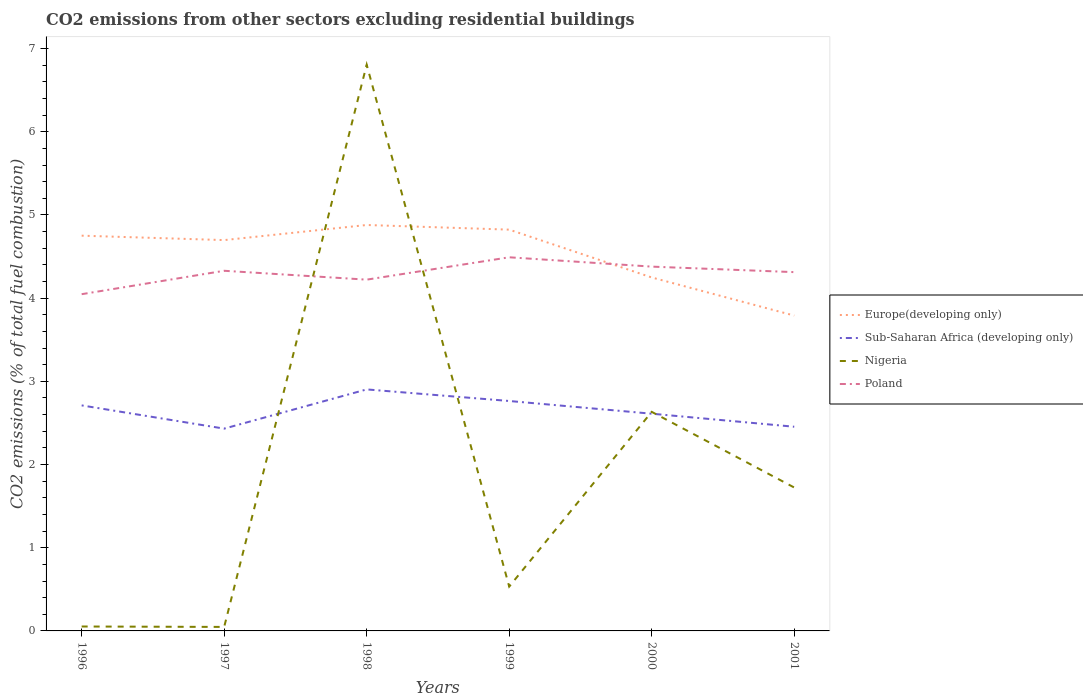Does the line corresponding to Sub-Saharan Africa (developing only) intersect with the line corresponding to Nigeria?
Offer a terse response. Yes. Is the number of lines equal to the number of legend labels?
Offer a very short reply. Yes. Across all years, what is the maximum total CO2 emitted in Poland?
Your response must be concise. 4.05. What is the total total CO2 emitted in Sub-Saharan Africa (developing only) in the graph?
Provide a short and direct response. 0.26. What is the difference between the highest and the second highest total CO2 emitted in Nigeria?
Offer a very short reply. 6.76. How many lines are there?
Offer a very short reply. 4. How many years are there in the graph?
Your answer should be very brief. 6. Does the graph contain grids?
Offer a terse response. No. Where does the legend appear in the graph?
Offer a very short reply. Center right. What is the title of the graph?
Ensure brevity in your answer.  CO2 emissions from other sectors excluding residential buildings. Does "Congo (Republic)" appear as one of the legend labels in the graph?
Make the answer very short. No. What is the label or title of the X-axis?
Make the answer very short. Years. What is the label or title of the Y-axis?
Offer a terse response. CO2 emissions (% of total fuel combustion). What is the CO2 emissions (% of total fuel combustion) in Europe(developing only) in 1996?
Give a very brief answer. 4.75. What is the CO2 emissions (% of total fuel combustion) of Sub-Saharan Africa (developing only) in 1996?
Make the answer very short. 2.71. What is the CO2 emissions (% of total fuel combustion) of Nigeria in 1996?
Offer a terse response. 0.05. What is the CO2 emissions (% of total fuel combustion) of Poland in 1996?
Ensure brevity in your answer.  4.05. What is the CO2 emissions (% of total fuel combustion) of Europe(developing only) in 1997?
Keep it short and to the point. 4.7. What is the CO2 emissions (% of total fuel combustion) in Sub-Saharan Africa (developing only) in 1997?
Your response must be concise. 2.43. What is the CO2 emissions (% of total fuel combustion) of Nigeria in 1997?
Offer a very short reply. 0.05. What is the CO2 emissions (% of total fuel combustion) in Poland in 1997?
Make the answer very short. 4.33. What is the CO2 emissions (% of total fuel combustion) of Europe(developing only) in 1998?
Offer a very short reply. 4.88. What is the CO2 emissions (% of total fuel combustion) in Sub-Saharan Africa (developing only) in 1998?
Your answer should be very brief. 2.9. What is the CO2 emissions (% of total fuel combustion) in Nigeria in 1998?
Your answer should be compact. 6.81. What is the CO2 emissions (% of total fuel combustion) in Poland in 1998?
Keep it short and to the point. 4.22. What is the CO2 emissions (% of total fuel combustion) in Europe(developing only) in 1999?
Keep it short and to the point. 4.82. What is the CO2 emissions (% of total fuel combustion) in Sub-Saharan Africa (developing only) in 1999?
Provide a short and direct response. 2.76. What is the CO2 emissions (% of total fuel combustion) of Nigeria in 1999?
Give a very brief answer. 0.53. What is the CO2 emissions (% of total fuel combustion) of Poland in 1999?
Your answer should be compact. 4.49. What is the CO2 emissions (% of total fuel combustion) of Europe(developing only) in 2000?
Ensure brevity in your answer.  4.25. What is the CO2 emissions (% of total fuel combustion) in Sub-Saharan Africa (developing only) in 2000?
Ensure brevity in your answer.  2.61. What is the CO2 emissions (% of total fuel combustion) in Nigeria in 2000?
Make the answer very short. 2.63. What is the CO2 emissions (% of total fuel combustion) in Poland in 2000?
Your response must be concise. 4.38. What is the CO2 emissions (% of total fuel combustion) of Europe(developing only) in 2001?
Your response must be concise. 3.79. What is the CO2 emissions (% of total fuel combustion) of Sub-Saharan Africa (developing only) in 2001?
Give a very brief answer. 2.45. What is the CO2 emissions (% of total fuel combustion) of Nigeria in 2001?
Keep it short and to the point. 1.72. What is the CO2 emissions (% of total fuel combustion) in Poland in 2001?
Offer a terse response. 4.31. Across all years, what is the maximum CO2 emissions (% of total fuel combustion) of Europe(developing only)?
Make the answer very short. 4.88. Across all years, what is the maximum CO2 emissions (% of total fuel combustion) in Sub-Saharan Africa (developing only)?
Your response must be concise. 2.9. Across all years, what is the maximum CO2 emissions (% of total fuel combustion) of Nigeria?
Your answer should be very brief. 6.81. Across all years, what is the maximum CO2 emissions (% of total fuel combustion) of Poland?
Make the answer very short. 4.49. Across all years, what is the minimum CO2 emissions (% of total fuel combustion) in Europe(developing only)?
Your response must be concise. 3.79. Across all years, what is the minimum CO2 emissions (% of total fuel combustion) in Sub-Saharan Africa (developing only)?
Offer a very short reply. 2.43. Across all years, what is the minimum CO2 emissions (% of total fuel combustion) of Nigeria?
Ensure brevity in your answer.  0.05. Across all years, what is the minimum CO2 emissions (% of total fuel combustion) in Poland?
Offer a terse response. 4.05. What is the total CO2 emissions (% of total fuel combustion) of Europe(developing only) in the graph?
Offer a terse response. 27.19. What is the total CO2 emissions (% of total fuel combustion) in Sub-Saharan Africa (developing only) in the graph?
Your answer should be compact. 15.88. What is the total CO2 emissions (% of total fuel combustion) of Nigeria in the graph?
Offer a very short reply. 11.8. What is the total CO2 emissions (% of total fuel combustion) in Poland in the graph?
Offer a terse response. 25.78. What is the difference between the CO2 emissions (% of total fuel combustion) in Europe(developing only) in 1996 and that in 1997?
Give a very brief answer. 0.05. What is the difference between the CO2 emissions (% of total fuel combustion) in Sub-Saharan Africa (developing only) in 1996 and that in 1997?
Keep it short and to the point. 0.28. What is the difference between the CO2 emissions (% of total fuel combustion) in Nigeria in 1996 and that in 1997?
Give a very brief answer. 0.01. What is the difference between the CO2 emissions (% of total fuel combustion) of Poland in 1996 and that in 1997?
Offer a terse response. -0.28. What is the difference between the CO2 emissions (% of total fuel combustion) in Europe(developing only) in 1996 and that in 1998?
Ensure brevity in your answer.  -0.13. What is the difference between the CO2 emissions (% of total fuel combustion) in Sub-Saharan Africa (developing only) in 1996 and that in 1998?
Keep it short and to the point. -0.19. What is the difference between the CO2 emissions (% of total fuel combustion) in Nigeria in 1996 and that in 1998?
Your answer should be compact. -6.75. What is the difference between the CO2 emissions (% of total fuel combustion) in Poland in 1996 and that in 1998?
Ensure brevity in your answer.  -0.17. What is the difference between the CO2 emissions (% of total fuel combustion) of Europe(developing only) in 1996 and that in 1999?
Give a very brief answer. -0.07. What is the difference between the CO2 emissions (% of total fuel combustion) in Sub-Saharan Africa (developing only) in 1996 and that in 1999?
Provide a short and direct response. -0.05. What is the difference between the CO2 emissions (% of total fuel combustion) in Nigeria in 1996 and that in 1999?
Provide a succinct answer. -0.48. What is the difference between the CO2 emissions (% of total fuel combustion) in Poland in 1996 and that in 1999?
Provide a short and direct response. -0.44. What is the difference between the CO2 emissions (% of total fuel combustion) in Europe(developing only) in 1996 and that in 2000?
Provide a succinct answer. 0.5. What is the difference between the CO2 emissions (% of total fuel combustion) in Sub-Saharan Africa (developing only) in 1996 and that in 2000?
Your answer should be compact. 0.1. What is the difference between the CO2 emissions (% of total fuel combustion) of Nigeria in 1996 and that in 2000?
Your answer should be compact. -2.58. What is the difference between the CO2 emissions (% of total fuel combustion) of Poland in 1996 and that in 2000?
Offer a terse response. -0.33. What is the difference between the CO2 emissions (% of total fuel combustion) of Europe(developing only) in 1996 and that in 2001?
Give a very brief answer. 0.96. What is the difference between the CO2 emissions (% of total fuel combustion) of Sub-Saharan Africa (developing only) in 1996 and that in 2001?
Your answer should be compact. 0.26. What is the difference between the CO2 emissions (% of total fuel combustion) of Nigeria in 1996 and that in 2001?
Provide a succinct answer. -1.67. What is the difference between the CO2 emissions (% of total fuel combustion) in Poland in 1996 and that in 2001?
Provide a succinct answer. -0.27. What is the difference between the CO2 emissions (% of total fuel combustion) in Europe(developing only) in 1997 and that in 1998?
Your answer should be very brief. -0.18. What is the difference between the CO2 emissions (% of total fuel combustion) in Sub-Saharan Africa (developing only) in 1997 and that in 1998?
Your response must be concise. -0.47. What is the difference between the CO2 emissions (% of total fuel combustion) in Nigeria in 1997 and that in 1998?
Your answer should be very brief. -6.76. What is the difference between the CO2 emissions (% of total fuel combustion) of Poland in 1997 and that in 1998?
Offer a very short reply. 0.11. What is the difference between the CO2 emissions (% of total fuel combustion) of Europe(developing only) in 1997 and that in 1999?
Your answer should be compact. -0.13. What is the difference between the CO2 emissions (% of total fuel combustion) of Sub-Saharan Africa (developing only) in 1997 and that in 1999?
Provide a short and direct response. -0.33. What is the difference between the CO2 emissions (% of total fuel combustion) of Nigeria in 1997 and that in 1999?
Give a very brief answer. -0.49. What is the difference between the CO2 emissions (% of total fuel combustion) in Poland in 1997 and that in 1999?
Offer a terse response. -0.16. What is the difference between the CO2 emissions (% of total fuel combustion) in Europe(developing only) in 1997 and that in 2000?
Ensure brevity in your answer.  0.45. What is the difference between the CO2 emissions (% of total fuel combustion) in Sub-Saharan Africa (developing only) in 1997 and that in 2000?
Offer a very short reply. -0.18. What is the difference between the CO2 emissions (% of total fuel combustion) of Nigeria in 1997 and that in 2000?
Provide a short and direct response. -2.59. What is the difference between the CO2 emissions (% of total fuel combustion) in Poland in 1997 and that in 2000?
Give a very brief answer. -0.05. What is the difference between the CO2 emissions (% of total fuel combustion) of Europe(developing only) in 1997 and that in 2001?
Your answer should be compact. 0.91. What is the difference between the CO2 emissions (% of total fuel combustion) in Sub-Saharan Africa (developing only) in 1997 and that in 2001?
Offer a very short reply. -0.02. What is the difference between the CO2 emissions (% of total fuel combustion) of Nigeria in 1997 and that in 2001?
Offer a terse response. -1.68. What is the difference between the CO2 emissions (% of total fuel combustion) in Poland in 1997 and that in 2001?
Your answer should be compact. 0.02. What is the difference between the CO2 emissions (% of total fuel combustion) in Europe(developing only) in 1998 and that in 1999?
Your answer should be compact. 0.06. What is the difference between the CO2 emissions (% of total fuel combustion) of Sub-Saharan Africa (developing only) in 1998 and that in 1999?
Ensure brevity in your answer.  0.14. What is the difference between the CO2 emissions (% of total fuel combustion) in Nigeria in 1998 and that in 1999?
Ensure brevity in your answer.  6.27. What is the difference between the CO2 emissions (% of total fuel combustion) of Poland in 1998 and that in 1999?
Your response must be concise. -0.27. What is the difference between the CO2 emissions (% of total fuel combustion) of Europe(developing only) in 1998 and that in 2000?
Your answer should be very brief. 0.63. What is the difference between the CO2 emissions (% of total fuel combustion) in Sub-Saharan Africa (developing only) in 1998 and that in 2000?
Make the answer very short. 0.29. What is the difference between the CO2 emissions (% of total fuel combustion) in Nigeria in 1998 and that in 2000?
Your response must be concise. 4.17. What is the difference between the CO2 emissions (% of total fuel combustion) in Poland in 1998 and that in 2000?
Your answer should be very brief. -0.16. What is the difference between the CO2 emissions (% of total fuel combustion) in Europe(developing only) in 1998 and that in 2001?
Offer a terse response. 1.09. What is the difference between the CO2 emissions (% of total fuel combustion) of Sub-Saharan Africa (developing only) in 1998 and that in 2001?
Your response must be concise. 0.45. What is the difference between the CO2 emissions (% of total fuel combustion) in Nigeria in 1998 and that in 2001?
Make the answer very short. 5.08. What is the difference between the CO2 emissions (% of total fuel combustion) of Poland in 1998 and that in 2001?
Your answer should be very brief. -0.09. What is the difference between the CO2 emissions (% of total fuel combustion) of Europe(developing only) in 1999 and that in 2000?
Provide a short and direct response. 0.57. What is the difference between the CO2 emissions (% of total fuel combustion) in Sub-Saharan Africa (developing only) in 1999 and that in 2000?
Offer a very short reply. 0.15. What is the difference between the CO2 emissions (% of total fuel combustion) in Nigeria in 1999 and that in 2000?
Offer a very short reply. -2.1. What is the difference between the CO2 emissions (% of total fuel combustion) of Poland in 1999 and that in 2000?
Provide a succinct answer. 0.11. What is the difference between the CO2 emissions (% of total fuel combustion) in Europe(developing only) in 1999 and that in 2001?
Ensure brevity in your answer.  1.03. What is the difference between the CO2 emissions (% of total fuel combustion) in Sub-Saharan Africa (developing only) in 1999 and that in 2001?
Your response must be concise. 0.31. What is the difference between the CO2 emissions (% of total fuel combustion) of Nigeria in 1999 and that in 2001?
Your answer should be compact. -1.19. What is the difference between the CO2 emissions (% of total fuel combustion) of Poland in 1999 and that in 2001?
Your answer should be compact. 0.18. What is the difference between the CO2 emissions (% of total fuel combustion) in Europe(developing only) in 2000 and that in 2001?
Offer a very short reply. 0.46. What is the difference between the CO2 emissions (% of total fuel combustion) of Sub-Saharan Africa (developing only) in 2000 and that in 2001?
Give a very brief answer. 0.16. What is the difference between the CO2 emissions (% of total fuel combustion) in Nigeria in 2000 and that in 2001?
Provide a succinct answer. 0.91. What is the difference between the CO2 emissions (% of total fuel combustion) in Poland in 2000 and that in 2001?
Offer a terse response. 0.07. What is the difference between the CO2 emissions (% of total fuel combustion) in Europe(developing only) in 1996 and the CO2 emissions (% of total fuel combustion) in Sub-Saharan Africa (developing only) in 1997?
Offer a terse response. 2.32. What is the difference between the CO2 emissions (% of total fuel combustion) in Europe(developing only) in 1996 and the CO2 emissions (% of total fuel combustion) in Nigeria in 1997?
Ensure brevity in your answer.  4.7. What is the difference between the CO2 emissions (% of total fuel combustion) of Europe(developing only) in 1996 and the CO2 emissions (% of total fuel combustion) of Poland in 1997?
Offer a terse response. 0.42. What is the difference between the CO2 emissions (% of total fuel combustion) in Sub-Saharan Africa (developing only) in 1996 and the CO2 emissions (% of total fuel combustion) in Nigeria in 1997?
Your answer should be compact. 2.66. What is the difference between the CO2 emissions (% of total fuel combustion) in Sub-Saharan Africa (developing only) in 1996 and the CO2 emissions (% of total fuel combustion) in Poland in 1997?
Provide a succinct answer. -1.62. What is the difference between the CO2 emissions (% of total fuel combustion) in Nigeria in 1996 and the CO2 emissions (% of total fuel combustion) in Poland in 1997?
Give a very brief answer. -4.28. What is the difference between the CO2 emissions (% of total fuel combustion) of Europe(developing only) in 1996 and the CO2 emissions (% of total fuel combustion) of Sub-Saharan Africa (developing only) in 1998?
Your response must be concise. 1.85. What is the difference between the CO2 emissions (% of total fuel combustion) of Europe(developing only) in 1996 and the CO2 emissions (% of total fuel combustion) of Nigeria in 1998?
Your response must be concise. -2.06. What is the difference between the CO2 emissions (% of total fuel combustion) of Europe(developing only) in 1996 and the CO2 emissions (% of total fuel combustion) of Poland in 1998?
Your answer should be very brief. 0.53. What is the difference between the CO2 emissions (% of total fuel combustion) in Sub-Saharan Africa (developing only) in 1996 and the CO2 emissions (% of total fuel combustion) in Nigeria in 1998?
Your response must be concise. -4.1. What is the difference between the CO2 emissions (% of total fuel combustion) of Sub-Saharan Africa (developing only) in 1996 and the CO2 emissions (% of total fuel combustion) of Poland in 1998?
Provide a short and direct response. -1.51. What is the difference between the CO2 emissions (% of total fuel combustion) in Nigeria in 1996 and the CO2 emissions (% of total fuel combustion) in Poland in 1998?
Your answer should be compact. -4.17. What is the difference between the CO2 emissions (% of total fuel combustion) of Europe(developing only) in 1996 and the CO2 emissions (% of total fuel combustion) of Sub-Saharan Africa (developing only) in 1999?
Ensure brevity in your answer.  1.99. What is the difference between the CO2 emissions (% of total fuel combustion) in Europe(developing only) in 1996 and the CO2 emissions (% of total fuel combustion) in Nigeria in 1999?
Give a very brief answer. 4.22. What is the difference between the CO2 emissions (% of total fuel combustion) of Europe(developing only) in 1996 and the CO2 emissions (% of total fuel combustion) of Poland in 1999?
Provide a succinct answer. 0.26. What is the difference between the CO2 emissions (% of total fuel combustion) in Sub-Saharan Africa (developing only) in 1996 and the CO2 emissions (% of total fuel combustion) in Nigeria in 1999?
Your answer should be compact. 2.18. What is the difference between the CO2 emissions (% of total fuel combustion) of Sub-Saharan Africa (developing only) in 1996 and the CO2 emissions (% of total fuel combustion) of Poland in 1999?
Provide a short and direct response. -1.78. What is the difference between the CO2 emissions (% of total fuel combustion) in Nigeria in 1996 and the CO2 emissions (% of total fuel combustion) in Poland in 1999?
Offer a terse response. -4.44. What is the difference between the CO2 emissions (% of total fuel combustion) of Europe(developing only) in 1996 and the CO2 emissions (% of total fuel combustion) of Sub-Saharan Africa (developing only) in 2000?
Make the answer very short. 2.14. What is the difference between the CO2 emissions (% of total fuel combustion) of Europe(developing only) in 1996 and the CO2 emissions (% of total fuel combustion) of Nigeria in 2000?
Keep it short and to the point. 2.12. What is the difference between the CO2 emissions (% of total fuel combustion) in Europe(developing only) in 1996 and the CO2 emissions (% of total fuel combustion) in Poland in 2000?
Your answer should be compact. 0.37. What is the difference between the CO2 emissions (% of total fuel combustion) of Sub-Saharan Africa (developing only) in 1996 and the CO2 emissions (% of total fuel combustion) of Nigeria in 2000?
Make the answer very short. 0.08. What is the difference between the CO2 emissions (% of total fuel combustion) in Sub-Saharan Africa (developing only) in 1996 and the CO2 emissions (% of total fuel combustion) in Poland in 2000?
Keep it short and to the point. -1.67. What is the difference between the CO2 emissions (% of total fuel combustion) in Nigeria in 1996 and the CO2 emissions (% of total fuel combustion) in Poland in 2000?
Make the answer very short. -4.33. What is the difference between the CO2 emissions (% of total fuel combustion) of Europe(developing only) in 1996 and the CO2 emissions (% of total fuel combustion) of Sub-Saharan Africa (developing only) in 2001?
Ensure brevity in your answer.  2.3. What is the difference between the CO2 emissions (% of total fuel combustion) in Europe(developing only) in 1996 and the CO2 emissions (% of total fuel combustion) in Nigeria in 2001?
Provide a succinct answer. 3.03. What is the difference between the CO2 emissions (% of total fuel combustion) in Europe(developing only) in 1996 and the CO2 emissions (% of total fuel combustion) in Poland in 2001?
Keep it short and to the point. 0.44. What is the difference between the CO2 emissions (% of total fuel combustion) in Sub-Saharan Africa (developing only) in 1996 and the CO2 emissions (% of total fuel combustion) in Nigeria in 2001?
Make the answer very short. 0.99. What is the difference between the CO2 emissions (% of total fuel combustion) in Sub-Saharan Africa (developing only) in 1996 and the CO2 emissions (% of total fuel combustion) in Poland in 2001?
Your answer should be compact. -1.6. What is the difference between the CO2 emissions (% of total fuel combustion) in Nigeria in 1996 and the CO2 emissions (% of total fuel combustion) in Poland in 2001?
Your response must be concise. -4.26. What is the difference between the CO2 emissions (% of total fuel combustion) of Europe(developing only) in 1997 and the CO2 emissions (% of total fuel combustion) of Sub-Saharan Africa (developing only) in 1998?
Provide a succinct answer. 1.79. What is the difference between the CO2 emissions (% of total fuel combustion) in Europe(developing only) in 1997 and the CO2 emissions (% of total fuel combustion) in Nigeria in 1998?
Offer a very short reply. -2.11. What is the difference between the CO2 emissions (% of total fuel combustion) in Europe(developing only) in 1997 and the CO2 emissions (% of total fuel combustion) in Poland in 1998?
Your response must be concise. 0.48. What is the difference between the CO2 emissions (% of total fuel combustion) in Sub-Saharan Africa (developing only) in 1997 and the CO2 emissions (% of total fuel combustion) in Nigeria in 1998?
Offer a terse response. -4.38. What is the difference between the CO2 emissions (% of total fuel combustion) in Sub-Saharan Africa (developing only) in 1997 and the CO2 emissions (% of total fuel combustion) in Poland in 1998?
Ensure brevity in your answer.  -1.79. What is the difference between the CO2 emissions (% of total fuel combustion) in Nigeria in 1997 and the CO2 emissions (% of total fuel combustion) in Poland in 1998?
Make the answer very short. -4.17. What is the difference between the CO2 emissions (% of total fuel combustion) in Europe(developing only) in 1997 and the CO2 emissions (% of total fuel combustion) in Sub-Saharan Africa (developing only) in 1999?
Offer a terse response. 1.93. What is the difference between the CO2 emissions (% of total fuel combustion) of Europe(developing only) in 1997 and the CO2 emissions (% of total fuel combustion) of Nigeria in 1999?
Your answer should be very brief. 4.16. What is the difference between the CO2 emissions (% of total fuel combustion) in Europe(developing only) in 1997 and the CO2 emissions (% of total fuel combustion) in Poland in 1999?
Ensure brevity in your answer.  0.21. What is the difference between the CO2 emissions (% of total fuel combustion) in Sub-Saharan Africa (developing only) in 1997 and the CO2 emissions (% of total fuel combustion) in Nigeria in 1999?
Your answer should be compact. 1.9. What is the difference between the CO2 emissions (% of total fuel combustion) in Sub-Saharan Africa (developing only) in 1997 and the CO2 emissions (% of total fuel combustion) in Poland in 1999?
Your response must be concise. -2.06. What is the difference between the CO2 emissions (% of total fuel combustion) of Nigeria in 1997 and the CO2 emissions (% of total fuel combustion) of Poland in 1999?
Offer a very short reply. -4.44. What is the difference between the CO2 emissions (% of total fuel combustion) of Europe(developing only) in 1997 and the CO2 emissions (% of total fuel combustion) of Sub-Saharan Africa (developing only) in 2000?
Provide a short and direct response. 2.09. What is the difference between the CO2 emissions (% of total fuel combustion) in Europe(developing only) in 1997 and the CO2 emissions (% of total fuel combustion) in Nigeria in 2000?
Give a very brief answer. 2.06. What is the difference between the CO2 emissions (% of total fuel combustion) of Europe(developing only) in 1997 and the CO2 emissions (% of total fuel combustion) of Poland in 2000?
Your answer should be very brief. 0.32. What is the difference between the CO2 emissions (% of total fuel combustion) in Sub-Saharan Africa (developing only) in 1997 and the CO2 emissions (% of total fuel combustion) in Nigeria in 2000?
Offer a very short reply. -0.2. What is the difference between the CO2 emissions (% of total fuel combustion) of Sub-Saharan Africa (developing only) in 1997 and the CO2 emissions (% of total fuel combustion) of Poland in 2000?
Ensure brevity in your answer.  -1.95. What is the difference between the CO2 emissions (% of total fuel combustion) of Nigeria in 1997 and the CO2 emissions (% of total fuel combustion) of Poland in 2000?
Your answer should be compact. -4.33. What is the difference between the CO2 emissions (% of total fuel combustion) of Europe(developing only) in 1997 and the CO2 emissions (% of total fuel combustion) of Sub-Saharan Africa (developing only) in 2001?
Provide a short and direct response. 2.24. What is the difference between the CO2 emissions (% of total fuel combustion) of Europe(developing only) in 1997 and the CO2 emissions (% of total fuel combustion) of Nigeria in 2001?
Your answer should be compact. 2.97. What is the difference between the CO2 emissions (% of total fuel combustion) of Europe(developing only) in 1997 and the CO2 emissions (% of total fuel combustion) of Poland in 2001?
Offer a terse response. 0.39. What is the difference between the CO2 emissions (% of total fuel combustion) of Sub-Saharan Africa (developing only) in 1997 and the CO2 emissions (% of total fuel combustion) of Nigeria in 2001?
Provide a succinct answer. 0.71. What is the difference between the CO2 emissions (% of total fuel combustion) in Sub-Saharan Africa (developing only) in 1997 and the CO2 emissions (% of total fuel combustion) in Poland in 2001?
Provide a succinct answer. -1.88. What is the difference between the CO2 emissions (% of total fuel combustion) in Nigeria in 1997 and the CO2 emissions (% of total fuel combustion) in Poland in 2001?
Your answer should be compact. -4.26. What is the difference between the CO2 emissions (% of total fuel combustion) of Europe(developing only) in 1998 and the CO2 emissions (% of total fuel combustion) of Sub-Saharan Africa (developing only) in 1999?
Your answer should be compact. 2.12. What is the difference between the CO2 emissions (% of total fuel combustion) of Europe(developing only) in 1998 and the CO2 emissions (% of total fuel combustion) of Nigeria in 1999?
Offer a very short reply. 4.35. What is the difference between the CO2 emissions (% of total fuel combustion) in Europe(developing only) in 1998 and the CO2 emissions (% of total fuel combustion) in Poland in 1999?
Give a very brief answer. 0.39. What is the difference between the CO2 emissions (% of total fuel combustion) in Sub-Saharan Africa (developing only) in 1998 and the CO2 emissions (% of total fuel combustion) in Nigeria in 1999?
Offer a very short reply. 2.37. What is the difference between the CO2 emissions (% of total fuel combustion) of Sub-Saharan Africa (developing only) in 1998 and the CO2 emissions (% of total fuel combustion) of Poland in 1999?
Give a very brief answer. -1.59. What is the difference between the CO2 emissions (% of total fuel combustion) of Nigeria in 1998 and the CO2 emissions (% of total fuel combustion) of Poland in 1999?
Your response must be concise. 2.32. What is the difference between the CO2 emissions (% of total fuel combustion) in Europe(developing only) in 1998 and the CO2 emissions (% of total fuel combustion) in Sub-Saharan Africa (developing only) in 2000?
Your answer should be compact. 2.27. What is the difference between the CO2 emissions (% of total fuel combustion) in Europe(developing only) in 1998 and the CO2 emissions (% of total fuel combustion) in Nigeria in 2000?
Your answer should be very brief. 2.25. What is the difference between the CO2 emissions (% of total fuel combustion) of Europe(developing only) in 1998 and the CO2 emissions (% of total fuel combustion) of Poland in 2000?
Keep it short and to the point. 0.5. What is the difference between the CO2 emissions (% of total fuel combustion) in Sub-Saharan Africa (developing only) in 1998 and the CO2 emissions (% of total fuel combustion) in Nigeria in 2000?
Offer a terse response. 0.27. What is the difference between the CO2 emissions (% of total fuel combustion) of Sub-Saharan Africa (developing only) in 1998 and the CO2 emissions (% of total fuel combustion) of Poland in 2000?
Offer a terse response. -1.48. What is the difference between the CO2 emissions (% of total fuel combustion) of Nigeria in 1998 and the CO2 emissions (% of total fuel combustion) of Poland in 2000?
Give a very brief answer. 2.43. What is the difference between the CO2 emissions (% of total fuel combustion) of Europe(developing only) in 1998 and the CO2 emissions (% of total fuel combustion) of Sub-Saharan Africa (developing only) in 2001?
Make the answer very short. 2.43. What is the difference between the CO2 emissions (% of total fuel combustion) in Europe(developing only) in 1998 and the CO2 emissions (% of total fuel combustion) in Nigeria in 2001?
Make the answer very short. 3.16. What is the difference between the CO2 emissions (% of total fuel combustion) of Europe(developing only) in 1998 and the CO2 emissions (% of total fuel combustion) of Poland in 2001?
Offer a terse response. 0.57. What is the difference between the CO2 emissions (% of total fuel combustion) of Sub-Saharan Africa (developing only) in 1998 and the CO2 emissions (% of total fuel combustion) of Nigeria in 2001?
Make the answer very short. 1.18. What is the difference between the CO2 emissions (% of total fuel combustion) in Sub-Saharan Africa (developing only) in 1998 and the CO2 emissions (% of total fuel combustion) in Poland in 2001?
Provide a short and direct response. -1.41. What is the difference between the CO2 emissions (% of total fuel combustion) of Nigeria in 1998 and the CO2 emissions (% of total fuel combustion) of Poland in 2001?
Offer a terse response. 2.49. What is the difference between the CO2 emissions (% of total fuel combustion) of Europe(developing only) in 1999 and the CO2 emissions (% of total fuel combustion) of Sub-Saharan Africa (developing only) in 2000?
Your response must be concise. 2.21. What is the difference between the CO2 emissions (% of total fuel combustion) of Europe(developing only) in 1999 and the CO2 emissions (% of total fuel combustion) of Nigeria in 2000?
Give a very brief answer. 2.19. What is the difference between the CO2 emissions (% of total fuel combustion) in Europe(developing only) in 1999 and the CO2 emissions (% of total fuel combustion) in Poland in 2000?
Your answer should be very brief. 0.44. What is the difference between the CO2 emissions (% of total fuel combustion) in Sub-Saharan Africa (developing only) in 1999 and the CO2 emissions (% of total fuel combustion) in Nigeria in 2000?
Your answer should be compact. 0.13. What is the difference between the CO2 emissions (% of total fuel combustion) in Sub-Saharan Africa (developing only) in 1999 and the CO2 emissions (% of total fuel combustion) in Poland in 2000?
Your answer should be very brief. -1.62. What is the difference between the CO2 emissions (% of total fuel combustion) of Nigeria in 1999 and the CO2 emissions (% of total fuel combustion) of Poland in 2000?
Ensure brevity in your answer.  -3.85. What is the difference between the CO2 emissions (% of total fuel combustion) of Europe(developing only) in 1999 and the CO2 emissions (% of total fuel combustion) of Sub-Saharan Africa (developing only) in 2001?
Offer a very short reply. 2.37. What is the difference between the CO2 emissions (% of total fuel combustion) in Europe(developing only) in 1999 and the CO2 emissions (% of total fuel combustion) in Poland in 2001?
Your answer should be very brief. 0.51. What is the difference between the CO2 emissions (% of total fuel combustion) in Sub-Saharan Africa (developing only) in 1999 and the CO2 emissions (% of total fuel combustion) in Nigeria in 2001?
Your answer should be compact. 1.04. What is the difference between the CO2 emissions (% of total fuel combustion) in Sub-Saharan Africa (developing only) in 1999 and the CO2 emissions (% of total fuel combustion) in Poland in 2001?
Offer a terse response. -1.55. What is the difference between the CO2 emissions (% of total fuel combustion) of Nigeria in 1999 and the CO2 emissions (% of total fuel combustion) of Poland in 2001?
Offer a very short reply. -3.78. What is the difference between the CO2 emissions (% of total fuel combustion) of Europe(developing only) in 2000 and the CO2 emissions (% of total fuel combustion) of Sub-Saharan Africa (developing only) in 2001?
Your answer should be very brief. 1.79. What is the difference between the CO2 emissions (% of total fuel combustion) of Europe(developing only) in 2000 and the CO2 emissions (% of total fuel combustion) of Nigeria in 2001?
Keep it short and to the point. 2.53. What is the difference between the CO2 emissions (% of total fuel combustion) of Europe(developing only) in 2000 and the CO2 emissions (% of total fuel combustion) of Poland in 2001?
Give a very brief answer. -0.06. What is the difference between the CO2 emissions (% of total fuel combustion) in Sub-Saharan Africa (developing only) in 2000 and the CO2 emissions (% of total fuel combustion) in Nigeria in 2001?
Provide a succinct answer. 0.89. What is the difference between the CO2 emissions (% of total fuel combustion) of Sub-Saharan Africa (developing only) in 2000 and the CO2 emissions (% of total fuel combustion) of Poland in 2001?
Offer a very short reply. -1.7. What is the difference between the CO2 emissions (% of total fuel combustion) in Nigeria in 2000 and the CO2 emissions (% of total fuel combustion) in Poland in 2001?
Your response must be concise. -1.68. What is the average CO2 emissions (% of total fuel combustion) in Europe(developing only) per year?
Provide a short and direct response. 4.53. What is the average CO2 emissions (% of total fuel combustion) in Sub-Saharan Africa (developing only) per year?
Offer a very short reply. 2.65. What is the average CO2 emissions (% of total fuel combustion) in Nigeria per year?
Your answer should be compact. 1.97. What is the average CO2 emissions (% of total fuel combustion) in Poland per year?
Ensure brevity in your answer.  4.3. In the year 1996, what is the difference between the CO2 emissions (% of total fuel combustion) of Europe(developing only) and CO2 emissions (% of total fuel combustion) of Sub-Saharan Africa (developing only)?
Your response must be concise. 2.04. In the year 1996, what is the difference between the CO2 emissions (% of total fuel combustion) of Europe(developing only) and CO2 emissions (% of total fuel combustion) of Nigeria?
Your answer should be very brief. 4.7. In the year 1996, what is the difference between the CO2 emissions (% of total fuel combustion) in Europe(developing only) and CO2 emissions (% of total fuel combustion) in Poland?
Your answer should be very brief. 0.7. In the year 1996, what is the difference between the CO2 emissions (% of total fuel combustion) of Sub-Saharan Africa (developing only) and CO2 emissions (% of total fuel combustion) of Nigeria?
Offer a terse response. 2.66. In the year 1996, what is the difference between the CO2 emissions (% of total fuel combustion) of Sub-Saharan Africa (developing only) and CO2 emissions (% of total fuel combustion) of Poland?
Give a very brief answer. -1.34. In the year 1996, what is the difference between the CO2 emissions (% of total fuel combustion) of Nigeria and CO2 emissions (% of total fuel combustion) of Poland?
Provide a short and direct response. -3.99. In the year 1997, what is the difference between the CO2 emissions (% of total fuel combustion) of Europe(developing only) and CO2 emissions (% of total fuel combustion) of Sub-Saharan Africa (developing only)?
Make the answer very short. 2.27. In the year 1997, what is the difference between the CO2 emissions (% of total fuel combustion) of Europe(developing only) and CO2 emissions (% of total fuel combustion) of Nigeria?
Keep it short and to the point. 4.65. In the year 1997, what is the difference between the CO2 emissions (% of total fuel combustion) in Europe(developing only) and CO2 emissions (% of total fuel combustion) in Poland?
Provide a succinct answer. 0.37. In the year 1997, what is the difference between the CO2 emissions (% of total fuel combustion) of Sub-Saharan Africa (developing only) and CO2 emissions (% of total fuel combustion) of Nigeria?
Your response must be concise. 2.38. In the year 1997, what is the difference between the CO2 emissions (% of total fuel combustion) of Sub-Saharan Africa (developing only) and CO2 emissions (% of total fuel combustion) of Poland?
Ensure brevity in your answer.  -1.9. In the year 1997, what is the difference between the CO2 emissions (% of total fuel combustion) in Nigeria and CO2 emissions (% of total fuel combustion) in Poland?
Your response must be concise. -4.28. In the year 1998, what is the difference between the CO2 emissions (% of total fuel combustion) of Europe(developing only) and CO2 emissions (% of total fuel combustion) of Sub-Saharan Africa (developing only)?
Your response must be concise. 1.98. In the year 1998, what is the difference between the CO2 emissions (% of total fuel combustion) of Europe(developing only) and CO2 emissions (% of total fuel combustion) of Nigeria?
Provide a succinct answer. -1.93. In the year 1998, what is the difference between the CO2 emissions (% of total fuel combustion) of Europe(developing only) and CO2 emissions (% of total fuel combustion) of Poland?
Ensure brevity in your answer.  0.66. In the year 1998, what is the difference between the CO2 emissions (% of total fuel combustion) in Sub-Saharan Africa (developing only) and CO2 emissions (% of total fuel combustion) in Nigeria?
Offer a terse response. -3.9. In the year 1998, what is the difference between the CO2 emissions (% of total fuel combustion) of Sub-Saharan Africa (developing only) and CO2 emissions (% of total fuel combustion) of Poland?
Provide a short and direct response. -1.32. In the year 1998, what is the difference between the CO2 emissions (% of total fuel combustion) in Nigeria and CO2 emissions (% of total fuel combustion) in Poland?
Provide a short and direct response. 2.58. In the year 1999, what is the difference between the CO2 emissions (% of total fuel combustion) in Europe(developing only) and CO2 emissions (% of total fuel combustion) in Sub-Saharan Africa (developing only)?
Offer a terse response. 2.06. In the year 1999, what is the difference between the CO2 emissions (% of total fuel combustion) in Europe(developing only) and CO2 emissions (% of total fuel combustion) in Nigeria?
Your answer should be very brief. 4.29. In the year 1999, what is the difference between the CO2 emissions (% of total fuel combustion) of Europe(developing only) and CO2 emissions (% of total fuel combustion) of Poland?
Make the answer very short. 0.33. In the year 1999, what is the difference between the CO2 emissions (% of total fuel combustion) in Sub-Saharan Africa (developing only) and CO2 emissions (% of total fuel combustion) in Nigeria?
Keep it short and to the point. 2.23. In the year 1999, what is the difference between the CO2 emissions (% of total fuel combustion) of Sub-Saharan Africa (developing only) and CO2 emissions (% of total fuel combustion) of Poland?
Offer a very short reply. -1.73. In the year 1999, what is the difference between the CO2 emissions (% of total fuel combustion) in Nigeria and CO2 emissions (% of total fuel combustion) in Poland?
Give a very brief answer. -3.96. In the year 2000, what is the difference between the CO2 emissions (% of total fuel combustion) in Europe(developing only) and CO2 emissions (% of total fuel combustion) in Sub-Saharan Africa (developing only)?
Make the answer very short. 1.64. In the year 2000, what is the difference between the CO2 emissions (% of total fuel combustion) of Europe(developing only) and CO2 emissions (% of total fuel combustion) of Nigeria?
Make the answer very short. 1.62. In the year 2000, what is the difference between the CO2 emissions (% of total fuel combustion) of Europe(developing only) and CO2 emissions (% of total fuel combustion) of Poland?
Give a very brief answer. -0.13. In the year 2000, what is the difference between the CO2 emissions (% of total fuel combustion) of Sub-Saharan Africa (developing only) and CO2 emissions (% of total fuel combustion) of Nigeria?
Offer a terse response. -0.02. In the year 2000, what is the difference between the CO2 emissions (% of total fuel combustion) of Sub-Saharan Africa (developing only) and CO2 emissions (% of total fuel combustion) of Poland?
Your response must be concise. -1.77. In the year 2000, what is the difference between the CO2 emissions (% of total fuel combustion) in Nigeria and CO2 emissions (% of total fuel combustion) in Poland?
Your answer should be very brief. -1.75. In the year 2001, what is the difference between the CO2 emissions (% of total fuel combustion) in Europe(developing only) and CO2 emissions (% of total fuel combustion) in Sub-Saharan Africa (developing only)?
Offer a terse response. 1.34. In the year 2001, what is the difference between the CO2 emissions (% of total fuel combustion) of Europe(developing only) and CO2 emissions (% of total fuel combustion) of Nigeria?
Keep it short and to the point. 2.07. In the year 2001, what is the difference between the CO2 emissions (% of total fuel combustion) in Europe(developing only) and CO2 emissions (% of total fuel combustion) in Poland?
Your answer should be very brief. -0.52. In the year 2001, what is the difference between the CO2 emissions (% of total fuel combustion) of Sub-Saharan Africa (developing only) and CO2 emissions (% of total fuel combustion) of Nigeria?
Make the answer very short. 0.73. In the year 2001, what is the difference between the CO2 emissions (% of total fuel combustion) of Sub-Saharan Africa (developing only) and CO2 emissions (% of total fuel combustion) of Poland?
Provide a short and direct response. -1.86. In the year 2001, what is the difference between the CO2 emissions (% of total fuel combustion) of Nigeria and CO2 emissions (% of total fuel combustion) of Poland?
Offer a very short reply. -2.59. What is the ratio of the CO2 emissions (% of total fuel combustion) in Europe(developing only) in 1996 to that in 1997?
Offer a terse response. 1.01. What is the ratio of the CO2 emissions (% of total fuel combustion) of Sub-Saharan Africa (developing only) in 1996 to that in 1997?
Make the answer very short. 1.11. What is the ratio of the CO2 emissions (% of total fuel combustion) of Nigeria in 1996 to that in 1997?
Offer a terse response. 1.1. What is the ratio of the CO2 emissions (% of total fuel combustion) of Poland in 1996 to that in 1997?
Offer a very short reply. 0.94. What is the ratio of the CO2 emissions (% of total fuel combustion) of Europe(developing only) in 1996 to that in 1998?
Make the answer very short. 0.97. What is the ratio of the CO2 emissions (% of total fuel combustion) of Sub-Saharan Africa (developing only) in 1996 to that in 1998?
Your response must be concise. 0.93. What is the ratio of the CO2 emissions (% of total fuel combustion) in Nigeria in 1996 to that in 1998?
Keep it short and to the point. 0.01. What is the ratio of the CO2 emissions (% of total fuel combustion) of Poland in 1996 to that in 1998?
Offer a very short reply. 0.96. What is the ratio of the CO2 emissions (% of total fuel combustion) in Europe(developing only) in 1996 to that in 1999?
Your answer should be very brief. 0.98. What is the ratio of the CO2 emissions (% of total fuel combustion) of Sub-Saharan Africa (developing only) in 1996 to that in 1999?
Provide a succinct answer. 0.98. What is the ratio of the CO2 emissions (% of total fuel combustion) of Nigeria in 1996 to that in 1999?
Provide a short and direct response. 0.1. What is the ratio of the CO2 emissions (% of total fuel combustion) in Poland in 1996 to that in 1999?
Make the answer very short. 0.9. What is the ratio of the CO2 emissions (% of total fuel combustion) of Europe(developing only) in 1996 to that in 2000?
Your answer should be compact. 1.12. What is the ratio of the CO2 emissions (% of total fuel combustion) of Sub-Saharan Africa (developing only) in 1996 to that in 2000?
Your answer should be compact. 1.04. What is the ratio of the CO2 emissions (% of total fuel combustion) in Nigeria in 1996 to that in 2000?
Provide a succinct answer. 0.02. What is the ratio of the CO2 emissions (% of total fuel combustion) of Poland in 1996 to that in 2000?
Offer a terse response. 0.92. What is the ratio of the CO2 emissions (% of total fuel combustion) in Europe(developing only) in 1996 to that in 2001?
Provide a short and direct response. 1.25. What is the ratio of the CO2 emissions (% of total fuel combustion) in Sub-Saharan Africa (developing only) in 1996 to that in 2001?
Ensure brevity in your answer.  1.1. What is the ratio of the CO2 emissions (% of total fuel combustion) in Nigeria in 1996 to that in 2001?
Give a very brief answer. 0.03. What is the ratio of the CO2 emissions (% of total fuel combustion) in Poland in 1996 to that in 2001?
Make the answer very short. 0.94. What is the ratio of the CO2 emissions (% of total fuel combustion) in Europe(developing only) in 1997 to that in 1998?
Provide a succinct answer. 0.96. What is the ratio of the CO2 emissions (% of total fuel combustion) in Sub-Saharan Africa (developing only) in 1997 to that in 1998?
Your answer should be compact. 0.84. What is the ratio of the CO2 emissions (% of total fuel combustion) in Nigeria in 1997 to that in 1998?
Ensure brevity in your answer.  0.01. What is the ratio of the CO2 emissions (% of total fuel combustion) in Poland in 1997 to that in 1998?
Give a very brief answer. 1.03. What is the ratio of the CO2 emissions (% of total fuel combustion) of Europe(developing only) in 1997 to that in 1999?
Make the answer very short. 0.97. What is the ratio of the CO2 emissions (% of total fuel combustion) in Sub-Saharan Africa (developing only) in 1997 to that in 1999?
Provide a succinct answer. 0.88. What is the ratio of the CO2 emissions (% of total fuel combustion) in Nigeria in 1997 to that in 1999?
Provide a succinct answer. 0.09. What is the ratio of the CO2 emissions (% of total fuel combustion) in Poland in 1997 to that in 1999?
Your answer should be compact. 0.96. What is the ratio of the CO2 emissions (% of total fuel combustion) in Europe(developing only) in 1997 to that in 2000?
Give a very brief answer. 1.11. What is the ratio of the CO2 emissions (% of total fuel combustion) of Sub-Saharan Africa (developing only) in 1997 to that in 2000?
Provide a short and direct response. 0.93. What is the ratio of the CO2 emissions (% of total fuel combustion) in Nigeria in 1997 to that in 2000?
Give a very brief answer. 0.02. What is the ratio of the CO2 emissions (% of total fuel combustion) in Poland in 1997 to that in 2000?
Provide a short and direct response. 0.99. What is the ratio of the CO2 emissions (% of total fuel combustion) of Europe(developing only) in 1997 to that in 2001?
Your response must be concise. 1.24. What is the ratio of the CO2 emissions (% of total fuel combustion) of Nigeria in 1997 to that in 2001?
Ensure brevity in your answer.  0.03. What is the ratio of the CO2 emissions (% of total fuel combustion) of Europe(developing only) in 1998 to that in 1999?
Offer a terse response. 1.01. What is the ratio of the CO2 emissions (% of total fuel combustion) in Sub-Saharan Africa (developing only) in 1998 to that in 1999?
Your answer should be compact. 1.05. What is the ratio of the CO2 emissions (% of total fuel combustion) in Nigeria in 1998 to that in 1999?
Give a very brief answer. 12.77. What is the ratio of the CO2 emissions (% of total fuel combustion) of Poland in 1998 to that in 1999?
Make the answer very short. 0.94. What is the ratio of the CO2 emissions (% of total fuel combustion) in Europe(developing only) in 1998 to that in 2000?
Keep it short and to the point. 1.15. What is the ratio of the CO2 emissions (% of total fuel combustion) in Sub-Saharan Africa (developing only) in 1998 to that in 2000?
Keep it short and to the point. 1.11. What is the ratio of the CO2 emissions (% of total fuel combustion) in Nigeria in 1998 to that in 2000?
Keep it short and to the point. 2.58. What is the ratio of the CO2 emissions (% of total fuel combustion) of Poland in 1998 to that in 2000?
Provide a succinct answer. 0.96. What is the ratio of the CO2 emissions (% of total fuel combustion) of Europe(developing only) in 1998 to that in 2001?
Your response must be concise. 1.29. What is the ratio of the CO2 emissions (% of total fuel combustion) in Sub-Saharan Africa (developing only) in 1998 to that in 2001?
Offer a very short reply. 1.18. What is the ratio of the CO2 emissions (% of total fuel combustion) in Nigeria in 1998 to that in 2001?
Keep it short and to the point. 3.95. What is the ratio of the CO2 emissions (% of total fuel combustion) in Poland in 1998 to that in 2001?
Provide a short and direct response. 0.98. What is the ratio of the CO2 emissions (% of total fuel combustion) of Europe(developing only) in 1999 to that in 2000?
Offer a very short reply. 1.14. What is the ratio of the CO2 emissions (% of total fuel combustion) of Sub-Saharan Africa (developing only) in 1999 to that in 2000?
Provide a succinct answer. 1.06. What is the ratio of the CO2 emissions (% of total fuel combustion) of Nigeria in 1999 to that in 2000?
Your response must be concise. 0.2. What is the ratio of the CO2 emissions (% of total fuel combustion) in Poland in 1999 to that in 2000?
Give a very brief answer. 1.03. What is the ratio of the CO2 emissions (% of total fuel combustion) in Europe(developing only) in 1999 to that in 2001?
Your answer should be compact. 1.27. What is the ratio of the CO2 emissions (% of total fuel combustion) of Sub-Saharan Africa (developing only) in 1999 to that in 2001?
Your answer should be compact. 1.13. What is the ratio of the CO2 emissions (% of total fuel combustion) of Nigeria in 1999 to that in 2001?
Give a very brief answer. 0.31. What is the ratio of the CO2 emissions (% of total fuel combustion) of Poland in 1999 to that in 2001?
Keep it short and to the point. 1.04. What is the ratio of the CO2 emissions (% of total fuel combustion) of Europe(developing only) in 2000 to that in 2001?
Make the answer very short. 1.12. What is the ratio of the CO2 emissions (% of total fuel combustion) of Sub-Saharan Africa (developing only) in 2000 to that in 2001?
Offer a very short reply. 1.06. What is the ratio of the CO2 emissions (% of total fuel combustion) of Nigeria in 2000 to that in 2001?
Offer a very short reply. 1.53. What is the ratio of the CO2 emissions (% of total fuel combustion) in Poland in 2000 to that in 2001?
Your answer should be compact. 1.02. What is the difference between the highest and the second highest CO2 emissions (% of total fuel combustion) of Europe(developing only)?
Ensure brevity in your answer.  0.06. What is the difference between the highest and the second highest CO2 emissions (% of total fuel combustion) of Sub-Saharan Africa (developing only)?
Your answer should be very brief. 0.14. What is the difference between the highest and the second highest CO2 emissions (% of total fuel combustion) of Nigeria?
Provide a succinct answer. 4.17. What is the difference between the highest and the second highest CO2 emissions (% of total fuel combustion) of Poland?
Your answer should be compact. 0.11. What is the difference between the highest and the lowest CO2 emissions (% of total fuel combustion) of Europe(developing only)?
Offer a very short reply. 1.09. What is the difference between the highest and the lowest CO2 emissions (% of total fuel combustion) of Sub-Saharan Africa (developing only)?
Provide a short and direct response. 0.47. What is the difference between the highest and the lowest CO2 emissions (% of total fuel combustion) of Nigeria?
Your answer should be very brief. 6.76. What is the difference between the highest and the lowest CO2 emissions (% of total fuel combustion) of Poland?
Give a very brief answer. 0.44. 